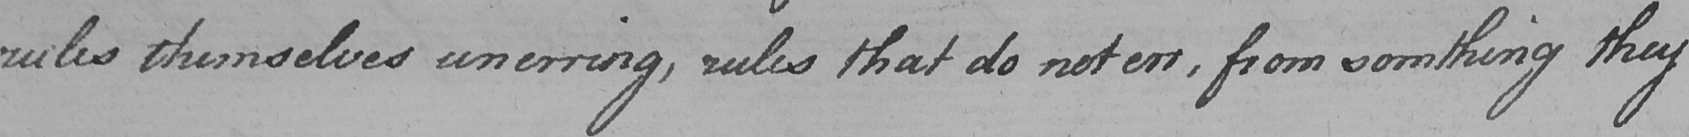Transcribe the text shown in this historical manuscript line. rules themselves unerring , rules that do not err , from somthing they 